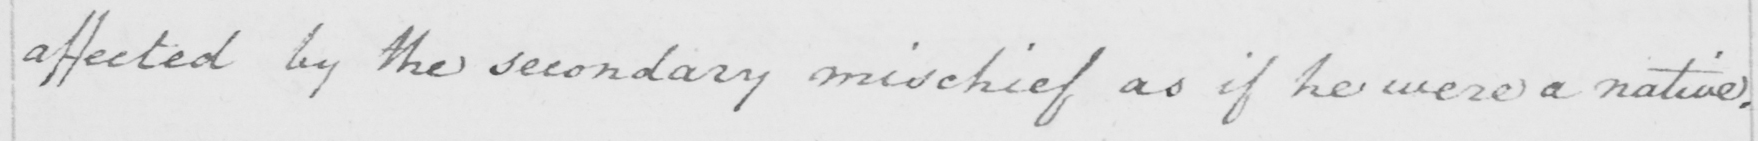Please provide the text content of this handwritten line. affected by the secondary mischief as if he were a native . 